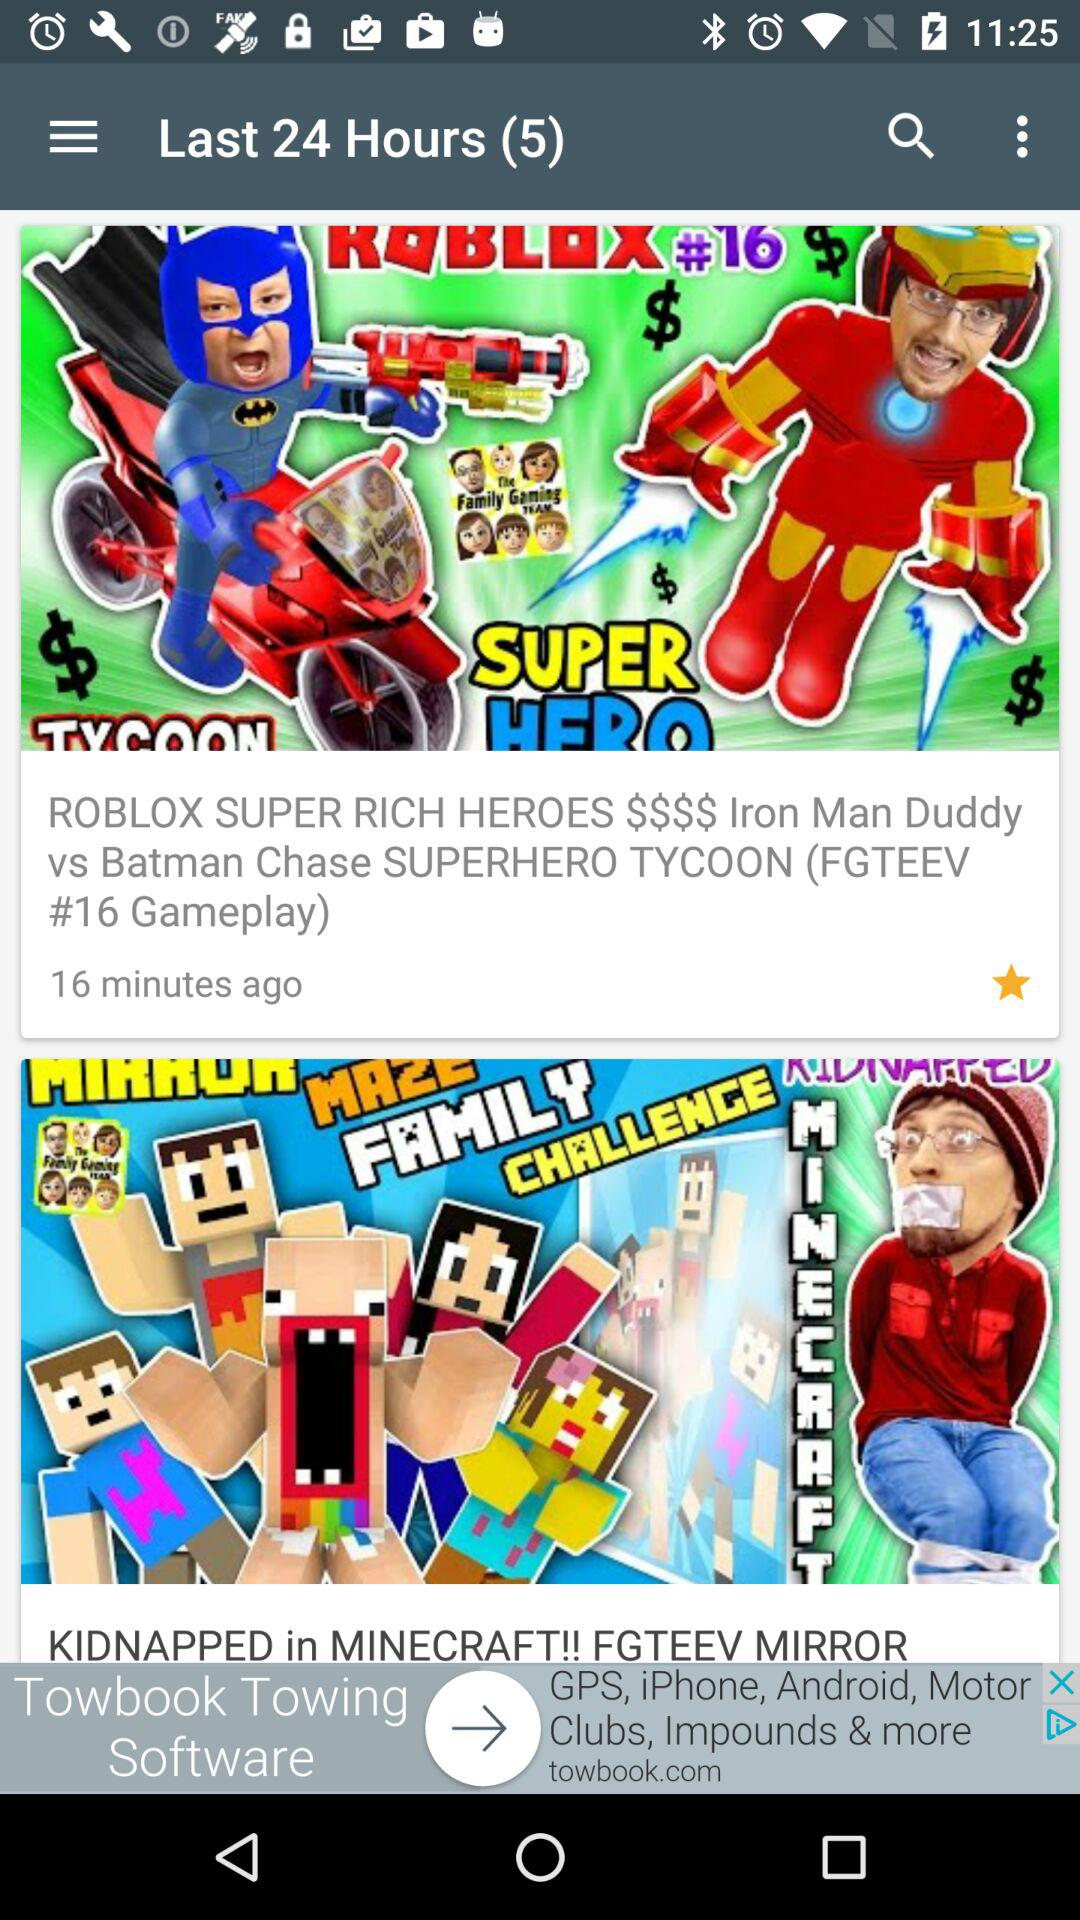Which animated video was uploaded 16 minutes ago? The animated video that was uploaded 16 minutes ago is "ROBLOX SUPER RICH HEROES $$$$ Iron Man Duddy vs Batman Chase SUPERHERO TYCOON (FGTEEV #16 Gameplay)". 